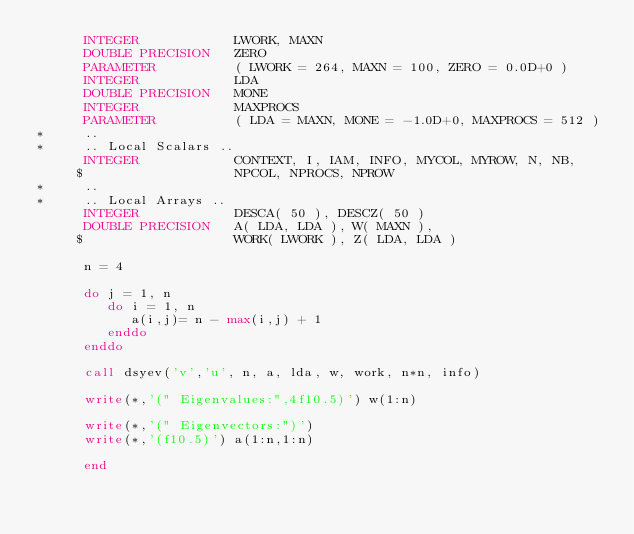<code> <loc_0><loc_0><loc_500><loc_500><_FORTRAN_>      INTEGER            LWORK, MAXN
      DOUBLE PRECISION   ZERO
      PARAMETER          ( LWORK = 264, MAXN = 100, ZERO = 0.0D+0 )
      INTEGER            LDA
      DOUBLE PRECISION   MONE
      INTEGER            MAXPROCS
      PARAMETER          ( LDA = MAXN, MONE = -1.0D+0, MAXPROCS = 512 )
*     ..
*     .. Local Scalars ..
      INTEGER            CONTEXT, I, IAM, INFO, MYCOL, MYROW, N, NB,
     $                   NPCOL, NPROCS, NPROW
*     ..
*     .. Local Arrays ..
      INTEGER            DESCA( 50 ), DESCZ( 50 )
      DOUBLE PRECISION   A( LDA, LDA ), W( MAXN ),
     $                   WORK( LWORK ), Z( LDA, LDA )

      n = 4

      do j = 1, n
         do i = 1, n
            a(i,j)= n - max(i,j) + 1
         enddo
      enddo

      call dsyev('v','u', n, a, lda, w, work, n*n, info)

      write(*,'(" Eigenvalues:",4f10.5)') w(1:n)

      write(*,'(" Eigenvectors:")') 
      write(*,'(f10.5)') a(1:n,1:n)

      end
</code> 